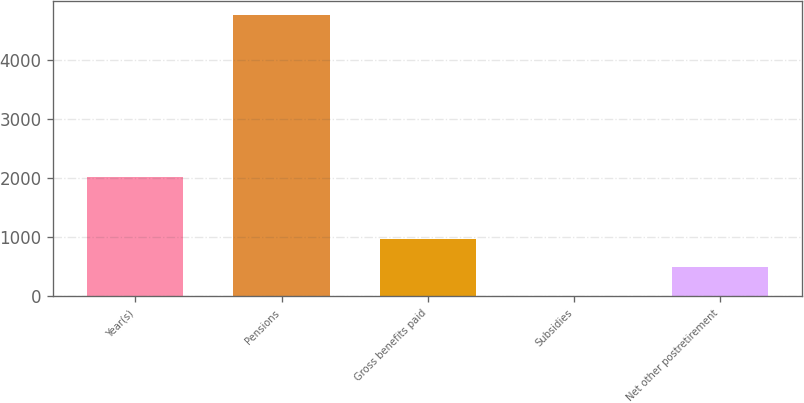Convert chart. <chart><loc_0><loc_0><loc_500><loc_500><bar_chart><fcel>Year(s)<fcel>Pensions<fcel>Gross benefits paid<fcel>Subsidies<fcel>Net other postretirement<nl><fcel>2018<fcel>4758<fcel>964.4<fcel>16<fcel>490.2<nl></chart> 